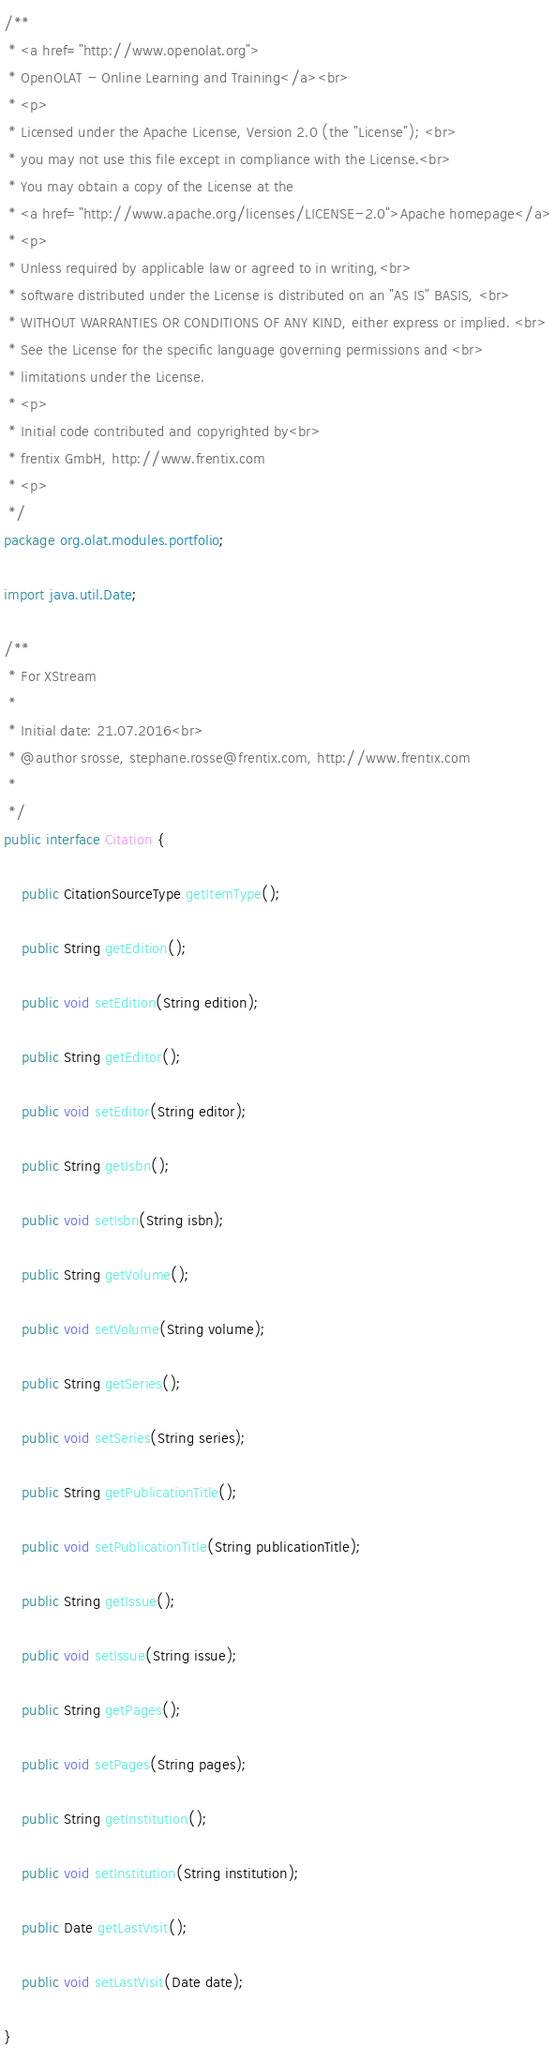Convert code to text. <code><loc_0><loc_0><loc_500><loc_500><_Java_>/**
 * <a href="http://www.openolat.org">
 * OpenOLAT - Online Learning and Training</a><br>
 * <p>
 * Licensed under the Apache License, Version 2.0 (the "License"); <br>
 * you may not use this file except in compliance with the License.<br>
 * You may obtain a copy of the License at the
 * <a href="http://www.apache.org/licenses/LICENSE-2.0">Apache homepage</a>
 * <p>
 * Unless required by applicable law or agreed to in writing,<br>
 * software distributed under the License is distributed on an "AS IS" BASIS, <br>
 * WITHOUT WARRANTIES OR CONDITIONS OF ANY KIND, either express or implied. <br>
 * See the License for the specific language governing permissions and <br>
 * limitations under the License.
 * <p>
 * Initial code contributed and copyrighted by<br>
 * frentix GmbH, http://www.frentix.com
 * <p>
 */
package org.olat.modules.portfolio;

import java.util.Date;

/**
 * For XStream
 * 
 * Initial date: 21.07.2016<br>
 * @author srosse, stephane.rosse@frentix.com, http://www.frentix.com
 *
 */
public interface Citation {
	
	public CitationSourceType getItemType();

	public String getEdition();

	public void setEdition(String edition);
	
	public String getEditor();
	
	public void setEditor(String editor);
	
	public String getIsbn();
	
	public void setIsbn(String isbn);

	public String getVolume();

	public void setVolume(String volume);

	public String getSeries();

	public void setSeries(String series);

	public String getPublicationTitle();

	public void setPublicationTitle(String publicationTitle);

	public String getIssue();

	public void setIssue(String issue);

	public String getPages();

	public void setPages(String pages);

	public String getInstitution();

	public void setInstitution(String institution);
	
	public Date getLastVisit();
	
	public void setLastVisit(Date date);

}
</code> 